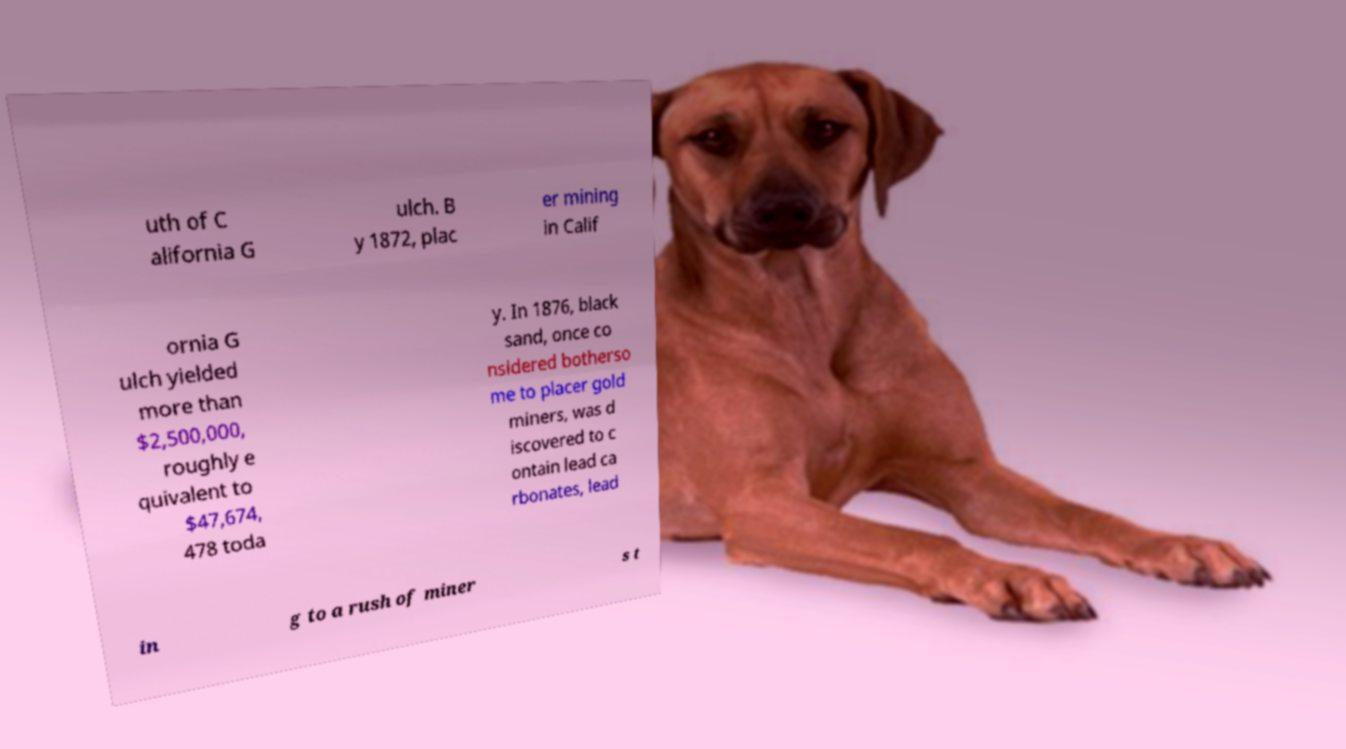Please identify and transcribe the text found in this image. uth of C alifornia G ulch. B y 1872, plac er mining in Calif ornia G ulch yielded more than $2,500,000, roughly e quivalent to $47,674, 478 toda y. In 1876, black sand, once co nsidered botherso me to placer gold miners, was d iscovered to c ontain lead ca rbonates, lead in g to a rush of miner s t 